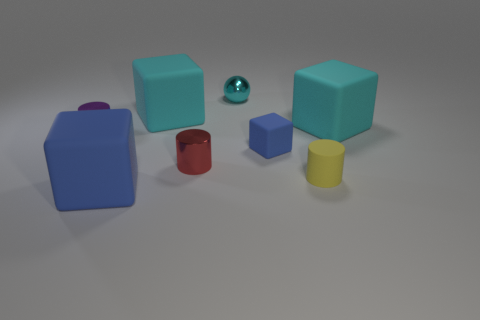There is another blue object that is the same shape as the small blue rubber thing; what is its size?
Your answer should be compact. Large. What number of other objects are the same shape as the small purple metal object?
Your answer should be very brief. 2. How many large matte things have the same color as the ball?
Your response must be concise. 2. What is the color of the tiny thing that is the same material as the tiny yellow cylinder?
Keep it short and to the point. Blue. Are there any cyan shiny things that have the same size as the yellow rubber cylinder?
Offer a terse response. Yes. Is the number of blocks that are to the right of the yellow object greater than the number of cyan matte things that are on the left side of the small purple metallic object?
Provide a short and direct response. Yes. Do the small object behind the purple cylinder and the tiny purple thing that is left of the tiny red cylinder have the same material?
Your response must be concise. Yes. The purple metallic thing that is the same size as the cyan shiny sphere is what shape?
Your response must be concise. Cylinder. Is there a tiny yellow matte thing that has the same shape as the small blue matte thing?
Provide a short and direct response. No. Do the large matte cube that is to the right of the metal sphere and the small metallic object that is behind the purple shiny thing have the same color?
Ensure brevity in your answer.  Yes. 